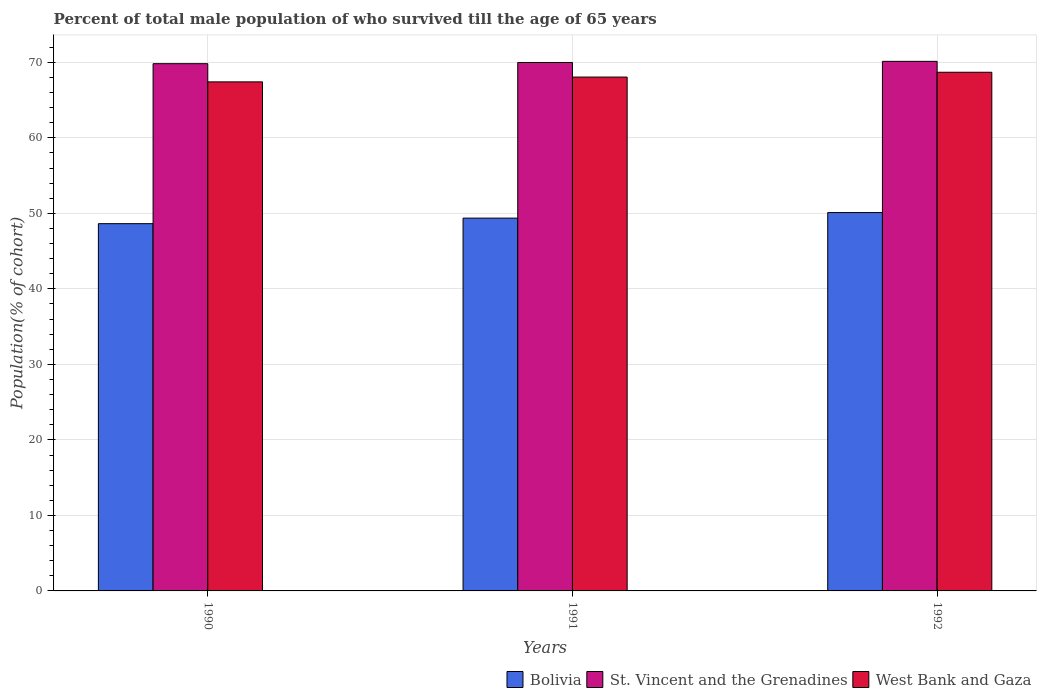How many different coloured bars are there?
Give a very brief answer. 3. Are the number of bars on each tick of the X-axis equal?
Give a very brief answer. Yes. How many bars are there on the 1st tick from the left?
Your answer should be compact. 3. How many bars are there on the 1st tick from the right?
Offer a terse response. 3. In how many cases, is the number of bars for a given year not equal to the number of legend labels?
Offer a very short reply. 0. What is the percentage of total male population who survived till the age of 65 years in Bolivia in 1992?
Offer a terse response. 50.11. Across all years, what is the maximum percentage of total male population who survived till the age of 65 years in Bolivia?
Provide a succinct answer. 50.11. Across all years, what is the minimum percentage of total male population who survived till the age of 65 years in West Bank and Gaza?
Offer a terse response. 67.42. In which year was the percentage of total male population who survived till the age of 65 years in Bolivia maximum?
Offer a terse response. 1992. What is the total percentage of total male population who survived till the age of 65 years in West Bank and Gaza in the graph?
Keep it short and to the point. 204.16. What is the difference between the percentage of total male population who survived till the age of 65 years in St. Vincent and the Grenadines in 1990 and that in 1992?
Keep it short and to the point. -0.31. What is the difference between the percentage of total male population who survived till the age of 65 years in West Bank and Gaza in 1992 and the percentage of total male population who survived till the age of 65 years in St. Vincent and the Grenadines in 1990?
Offer a very short reply. -1.14. What is the average percentage of total male population who survived till the age of 65 years in St. Vincent and the Grenadines per year?
Give a very brief answer. 69.98. In the year 1992, what is the difference between the percentage of total male population who survived till the age of 65 years in St. Vincent and the Grenadines and percentage of total male population who survived till the age of 65 years in Bolivia?
Your response must be concise. 20.03. What is the ratio of the percentage of total male population who survived till the age of 65 years in St. Vincent and the Grenadines in 1990 to that in 1991?
Provide a succinct answer. 1. What is the difference between the highest and the second highest percentage of total male population who survived till the age of 65 years in Bolivia?
Make the answer very short. 0.74. What is the difference between the highest and the lowest percentage of total male population who survived till the age of 65 years in St. Vincent and the Grenadines?
Your answer should be very brief. 0.31. What does the 3rd bar from the left in 1992 represents?
Provide a succinct answer. West Bank and Gaza. What does the 3rd bar from the right in 1992 represents?
Give a very brief answer. Bolivia. How many bars are there?
Offer a terse response. 9. Are all the bars in the graph horizontal?
Provide a short and direct response. No. How many years are there in the graph?
Provide a short and direct response. 3. What is the difference between two consecutive major ticks on the Y-axis?
Make the answer very short. 10. Are the values on the major ticks of Y-axis written in scientific E-notation?
Keep it short and to the point. No. Where does the legend appear in the graph?
Provide a succinct answer. Bottom right. How are the legend labels stacked?
Make the answer very short. Horizontal. What is the title of the graph?
Your response must be concise. Percent of total male population of who survived till the age of 65 years. What is the label or title of the X-axis?
Offer a terse response. Years. What is the label or title of the Y-axis?
Provide a short and direct response. Population(% of cohort). What is the Population(% of cohort) of Bolivia in 1990?
Make the answer very short. 48.64. What is the Population(% of cohort) in St. Vincent and the Grenadines in 1990?
Provide a succinct answer. 69.83. What is the Population(% of cohort) in West Bank and Gaza in 1990?
Your response must be concise. 67.42. What is the Population(% of cohort) in Bolivia in 1991?
Give a very brief answer. 49.37. What is the Population(% of cohort) of St. Vincent and the Grenadines in 1991?
Keep it short and to the point. 69.98. What is the Population(% of cohort) of West Bank and Gaza in 1991?
Your response must be concise. 68.05. What is the Population(% of cohort) in Bolivia in 1992?
Ensure brevity in your answer.  50.11. What is the Population(% of cohort) of St. Vincent and the Grenadines in 1992?
Your response must be concise. 70.13. What is the Population(% of cohort) of West Bank and Gaza in 1992?
Keep it short and to the point. 68.69. Across all years, what is the maximum Population(% of cohort) in Bolivia?
Give a very brief answer. 50.11. Across all years, what is the maximum Population(% of cohort) of St. Vincent and the Grenadines?
Provide a short and direct response. 70.13. Across all years, what is the maximum Population(% of cohort) in West Bank and Gaza?
Your response must be concise. 68.69. Across all years, what is the minimum Population(% of cohort) of Bolivia?
Offer a very short reply. 48.64. Across all years, what is the minimum Population(% of cohort) of St. Vincent and the Grenadines?
Your answer should be compact. 69.83. Across all years, what is the minimum Population(% of cohort) in West Bank and Gaza?
Your answer should be very brief. 67.42. What is the total Population(% of cohort) of Bolivia in the graph?
Keep it short and to the point. 148.12. What is the total Population(% of cohort) in St. Vincent and the Grenadines in the graph?
Your response must be concise. 209.94. What is the total Population(% of cohort) of West Bank and Gaza in the graph?
Your response must be concise. 204.16. What is the difference between the Population(% of cohort) in Bolivia in 1990 and that in 1991?
Provide a succinct answer. -0.74. What is the difference between the Population(% of cohort) in St. Vincent and the Grenadines in 1990 and that in 1991?
Your answer should be compact. -0.15. What is the difference between the Population(% of cohort) of West Bank and Gaza in 1990 and that in 1991?
Keep it short and to the point. -0.64. What is the difference between the Population(% of cohort) in Bolivia in 1990 and that in 1992?
Provide a short and direct response. -1.47. What is the difference between the Population(% of cohort) in St. Vincent and the Grenadines in 1990 and that in 1992?
Your answer should be compact. -0.31. What is the difference between the Population(% of cohort) of West Bank and Gaza in 1990 and that in 1992?
Provide a succinct answer. -1.27. What is the difference between the Population(% of cohort) of Bolivia in 1991 and that in 1992?
Your answer should be compact. -0.74. What is the difference between the Population(% of cohort) of St. Vincent and the Grenadines in 1991 and that in 1992?
Provide a succinct answer. -0.15. What is the difference between the Population(% of cohort) in West Bank and Gaza in 1991 and that in 1992?
Offer a very short reply. -0.64. What is the difference between the Population(% of cohort) in Bolivia in 1990 and the Population(% of cohort) in St. Vincent and the Grenadines in 1991?
Offer a very short reply. -21.34. What is the difference between the Population(% of cohort) in Bolivia in 1990 and the Population(% of cohort) in West Bank and Gaza in 1991?
Offer a terse response. -19.41. What is the difference between the Population(% of cohort) of St. Vincent and the Grenadines in 1990 and the Population(% of cohort) of West Bank and Gaza in 1991?
Ensure brevity in your answer.  1.77. What is the difference between the Population(% of cohort) in Bolivia in 1990 and the Population(% of cohort) in St. Vincent and the Grenadines in 1992?
Ensure brevity in your answer.  -21.5. What is the difference between the Population(% of cohort) of Bolivia in 1990 and the Population(% of cohort) of West Bank and Gaza in 1992?
Make the answer very short. -20.05. What is the difference between the Population(% of cohort) of St. Vincent and the Grenadines in 1990 and the Population(% of cohort) of West Bank and Gaza in 1992?
Make the answer very short. 1.14. What is the difference between the Population(% of cohort) of Bolivia in 1991 and the Population(% of cohort) of St. Vincent and the Grenadines in 1992?
Your response must be concise. -20.76. What is the difference between the Population(% of cohort) of Bolivia in 1991 and the Population(% of cohort) of West Bank and Gaza in 1992?
Make the answer very short. -19.32. What is the difference between the Population(% of cohort) of St. Vincent and the Grenadines in 1991 and the Population(% of cohort) of West Bank and Gaza in 1992?
Your response must be concise. 1.29. What is the average Population(% of cohort) of Bolivia per year?
Your answer should be compact. 49.37. What is the average Population(% of cohort) in St. Vincent and the Grenadines per year?
Provide a succinct answer. 69.98. What is the average Population(% of cohort) in West Bank and Gaza per year?
Keep it short and to the point. 68.05. In the year 1990, what is the difference between the Population(% of cohort) of Bolivia and Population(% of cohort) of St. Vincent and the Grenadines?
Make the answer very short. -21.19. In the year 1990, what is the difference between the Population(% of cohort) of Bolivia and Population(% of cohort) of West Bank and Gaza?
Provide a short and direct response. -18.78. In the year 1990, what is the difference between the Population(% of cohort) in St. Vincent and the Grenadines and Population(% of cohort) in West Bank and Gaza?
Provide a short and direct response. 2.41. In the year 1991, what is the difference between the Population(% of cohort) of Bolivia and Population(% of cohort) of St. Vincent and the Grenadines?
Give a very brief answer. -20.61. In the year 1991, what is the difference between the Population(% of cohort) in Bolivia and Population(% of cohort) in West Bank and Gaza?
Offer a very short reply. -18.68. In the year 1991, what is the difference between the Population(% of cohort) of St. Vincent and the Grenadines and Population(% of cohort) of West Bank and Gaza?
Provide a succinct answer. 1.93. In the year 1992, what is the difference between the Population(% of cohort) in Bolivia and Population(% of cohort) in St. Vincent and the Grenadines?
Give a very brief answer. -20.03. In the year 1992, what is the difference between the Population(% of cohort) in Bolivia and Population(% of cohort) in West Bank and Gaza?
Make the answer very short. -18.58. In the year 1992, what is the difference between the Population(% of cohort) of St. Vincent and the Grenadines and Population(% of cohort) of West Bank and Gaza?
Offer a very short reply. 1.44. What is the ratio of the Population(% of cohort) in Bolivia in 1990 to that in 1991?
Provide a short and direct response. 0.99. What is the ratio of the Population(% of cohort) of St. Vincent and the Grenadines in 1990 to that in 1991?
Make the answer very short. 1. What is the ratio of the Population(% of cohort) in West Bank and Gaza in 1990 to that in 1991?
Offer a terse response. 0.99. What is the ratio of the Population(% of cohort) in Bolivia in 1990 to that in 1992?
Provide a short and direct response. 0.97. What is the ratio of the Population(% of cohort) of St. Vincent and the Grenadines in 1990 to that in 1992?
Make the answer very short. 1. What is the ratio of the Population(% of cohort) of West Bank and Gaza in 1990 to that in 1992?
Keep it short and to the point. 0.98. What is the difference between the highest and the second highest Population(% of cohort) of Bolivia?
Ensure brevity in your answer.  0.74. What is the difference between the highest and the second highest Population(% of cohort) in St. Vincent and the Grenadines?
Offer a terse response. 0.15. What is the difference between the highest and the second highest Population(% of cohort) of West Bank and Gaza?
Your answer should be very brief. 0.64. What is the difference between the highest and the lowest Population(% of cohort) in Bolivia?
Offer a terse response. 1.47. What is the difference between the highest and the lowest Population(% of cohort) of St. Vincent and the Grenadines?
Provide a succinct answer. 0.31. What is the difference between the highest and the lowest Population(% of cohort) in West Bank and Gaza?
Give a very brief answer. 1.27. 